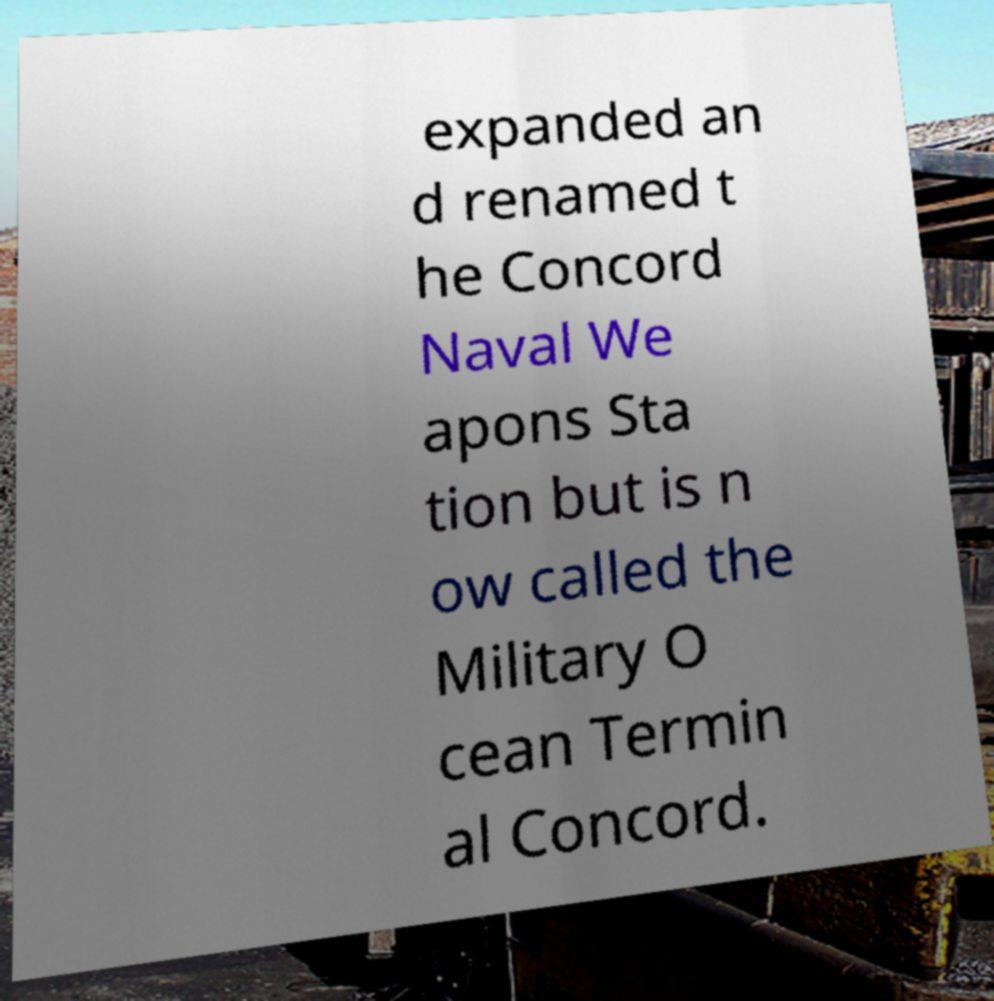For documentation purposes, I need the text within this image transcribed. Could you provide that? expanded an d renamed t he Concord Naval We apons Sta tion but is n ow called the Military O cean Termin al Concord. 